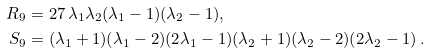Convert formula to latex. <formula><loc_0><loc_0><loc_500><loc_500>R _ { 9 } & = 2 7 \, \lambda _ { 1 } \lambda _ { 2 } ( \lambda _ { 1 } - 1 ) ( \lambda _ { 2 } - 1 ) , \\ S _ { 9 } & = ( \lambda _ { 1 } + 1 ) ( \lambda _ { 1 } - 2 ) ( 2 \lambda _ { 1 } - 1 ) ( \lambda _ { 2 } + 1 ) ( \lambda _ { 2 } - 2 ) ( 2 \lambda _ { 2 } - 1 ) \, .</formula> 